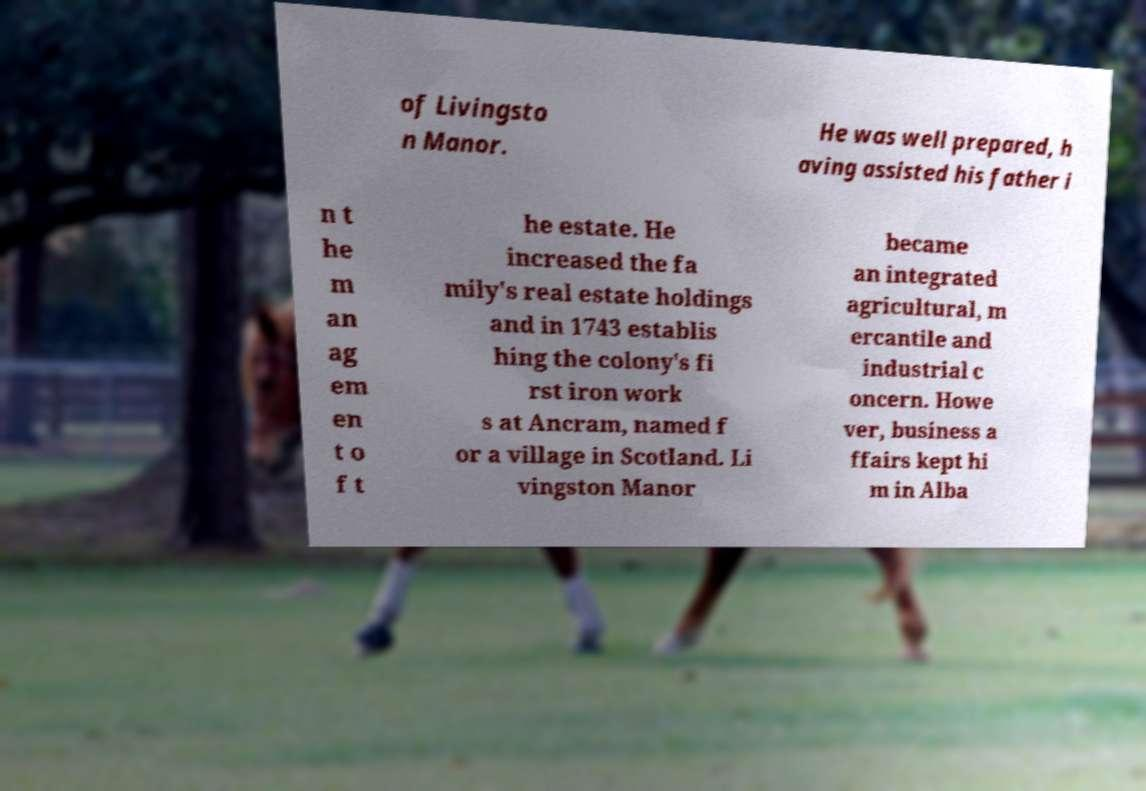Could you extract and type out the text from this image? of Livingsto n Manor. He was well prepared, h aving assisted his father i n t he m an ag em en t o f t he estate. He increased the fa mily's real estate holdings and in 1743 establis hing the colony's fi rst iron work s at Ancram, named f or a village in Scotland. Li vingston Manor became an integrated agricultural, m ercantile and industrial c oncern. Howe ver, business a ffairs kept hi m in Alba 